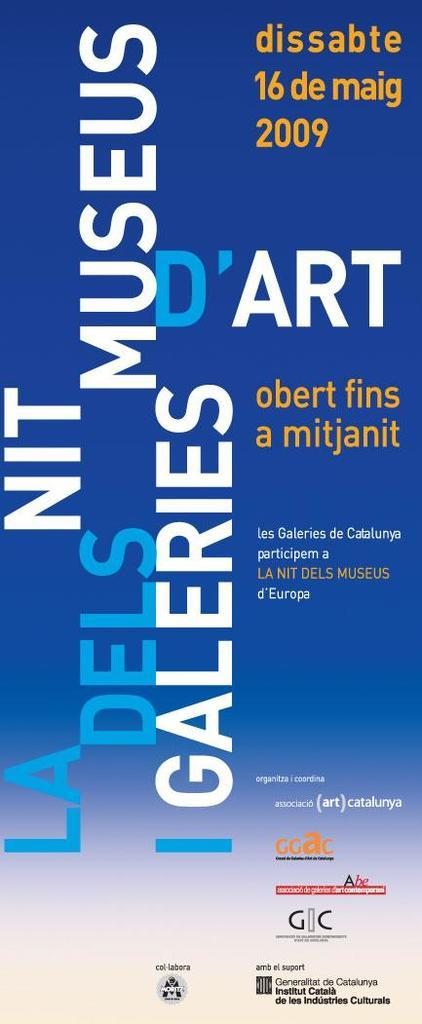<image>
Give a short and clear explanation of the subsequent image. A flyer advertises an event taking place in 2009. 